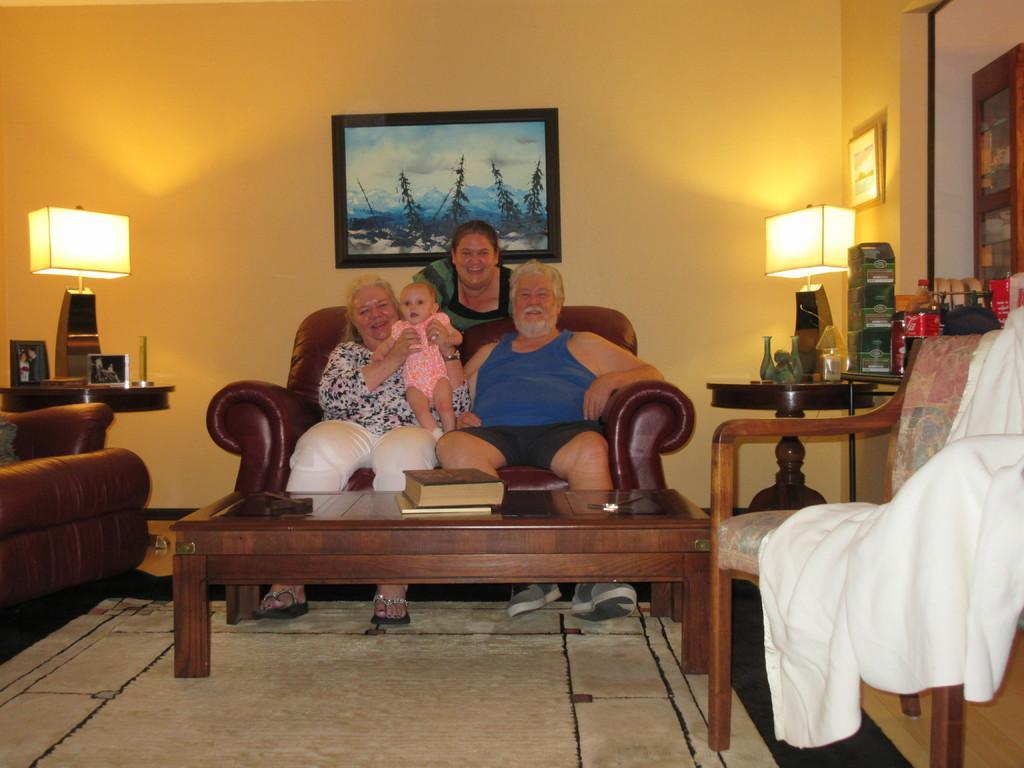In one or two sentences, can you explain what this image depicts? A couple are posing to camera with a baby sitting in a sofa. There is a woman standing behind them. 